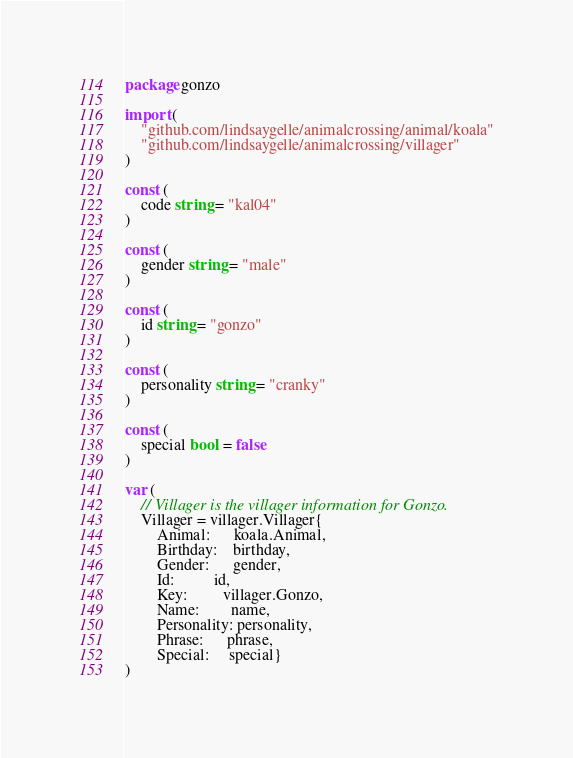Convert code to text. <code><loc_0><loc_0><loc_500><loc_500><_Go_>package gonzo

import (
	"github.com/lindsaygelle/animalcrossing/animal/koala"
	"github.com/lindsaygelle/animalcrossing/villager"
)

const (
	code string = "kal04"
)

const (
	gender string = "male"
)

const (
	id string = "gonzo"
)

const (
	personality string = "cranky"
)

const (
	special bool = false
)

var (
	// Villager is the villager information for Gonzo.
	Villager = villager.Villager{
		Animal:      koala.Animal,
		Birthday:    birthday,
		Gender:      gender,
		Id:          id,
		Key:         villager.Gonzo,
		Name:        name,
		Personality: personality,
		Phrase:      phrase,
		Special:     special}
)
</code> 